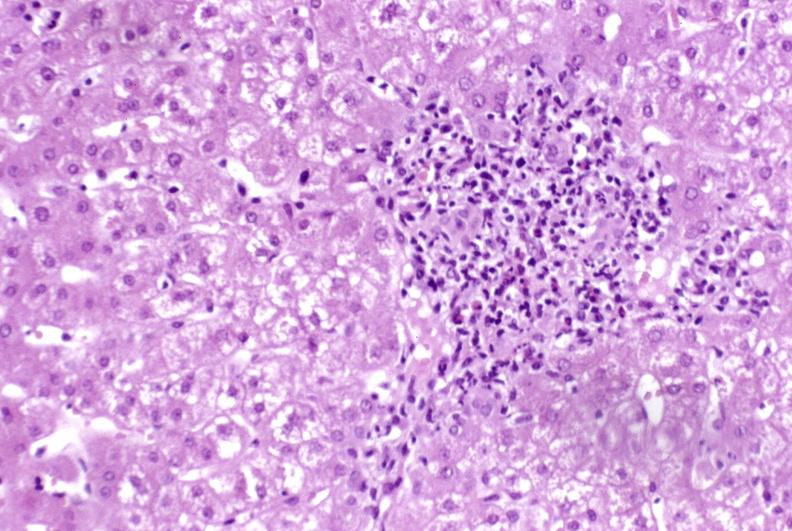s hepatobiliary present?
Answer the question using a single word or phrase. Yes 